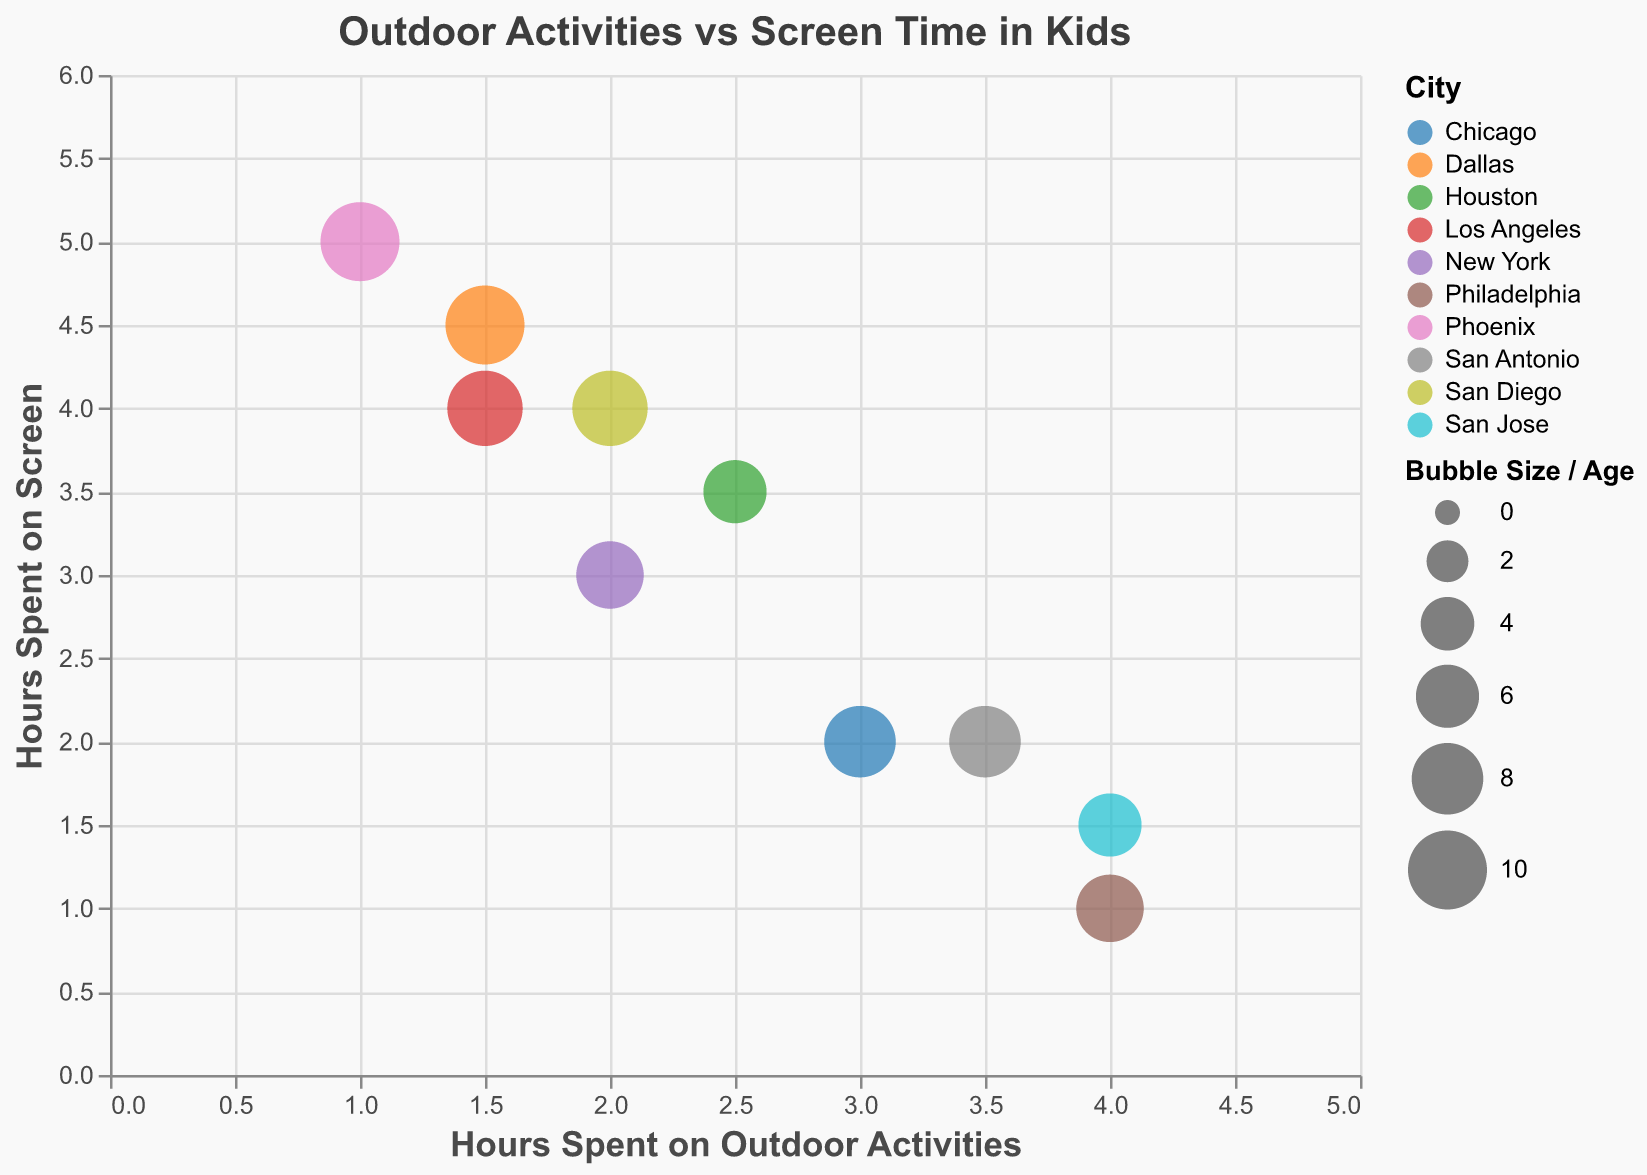What's the title of the chart? The title is usually displayed at the top of the chart. By referring to the figure, we can see the title which describes the content of the chart.
Answer: Outdoor Activities vs Screen Time in Kids Which child spends the most time on outdoor activities? To find out which child spends the most time on outdoor activities, look at the data points on the x-axis. The child with the highest value on the x-axis represents the most hours spent outdoors.
Answer: Fiona How many hours does Charlie spend on screen time? To find Charlie's screen time, locate Charlie's data point in the chart and refer to the y-axis value associated with it.
Answer: 2 hours Who has the lowest screen time and what is it? To find the child with the lowest screen time, look for the smallest value on the y-axis among all data points.
Answer: Fiona (1 hour) Compare Ethan and Jake: Who spends more hours on outdoor activities and by how much? Locate Ethan and Jake's data points. Ethan's outdoor activities are 1 hour and Jake's are 4 hours. Subtract Ethan's outdoor hours from Jake's outdoor hours.
Answer: Jake by 3 hours What is the average age of the kids in the chart? Sum the ages of all the children and divide by the number of children. The ages are 7, 9, 8, 6, 10, 7, 8, 9, 10, and 6. Calculate (7+9+8+6+10+7+8+9+10+6)/10.
Answer: 8 Which city has the child that spends the most time on screens? To find the city, locate the data point with the highest value on the y-axis (Ethan's point with 5 hours of screen time) and check its color/legend to find the corresponding city.
Answer: Phoenix Considering both screen time and outdoor activity, which child has the closest balance between these two activities? Examine the chart for the data points that are closest to the line x = y, indicating balanced hours. Check Fiona (4 outdoors, 1 screen), and Daisy (2.5 outdoors, 3.5 screen) and compare proportions.
Answer: Daisy What is the total number of cities represented in the chart? Look at the legend that indicates different colors for different locations. Count the distinct cities.
Answer: 10 Looking at children aged 8 or above, who spends the most time on outdoor activities? Identify children aged 8 or above (Charlie, Ethan, George, Hannah, Ian) and compare their hours spent on outdoor activities.
Answer: George 